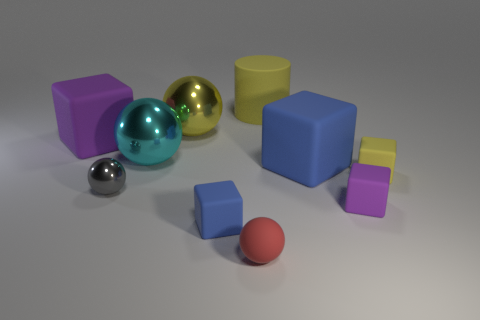Subtract all big blue blocks. How many blocks are left? 4 Subtract all cyan balls. How many balls are left? 3 Subtract 1 cubes. How many cubes are left? 4 Subtract all brown spheres. Subtract all red blocks. How many spheres are left? 4 Add 6 large blue blocks. How many large blue blocks are left? 7 Add 7 small balls. How many small balls exist? 9 Subtract 0 brown cubes. How many objects are left? 10 Subtract all balls. How many objects are left? 6 Subtract all small blue cubes. Subtract all blue metallic things. How many objects are left? 9 